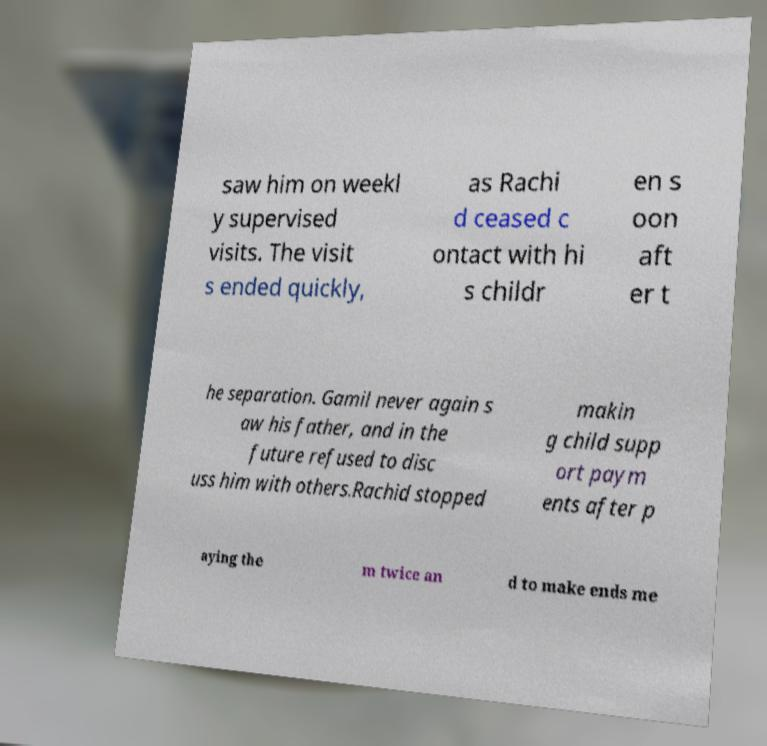Could you extract and type out the text from this image? saw him on weekl y supervised visits. The visit s ended quickly, as Rachi d ceased c ontact with hi s childr en s oon aft er t he separation. Gamil never again s aw his father, and in the future refused to disc uss him with others.Rachid stopped makin g child supp ort paym ents after p aying the m twice an d to make ends me 